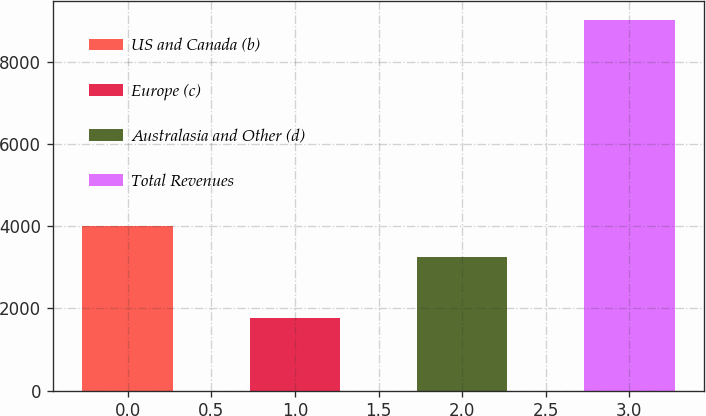Convert chart. <chart><loc_0><loc_0><loc_500><loc_500><bar_chart><fcel>US and Canada (b)<fcel>Europe (c)<fcel>Australasia and Other (d)<fcel>Total Revenues<nl><fcel>3998<fcel>1766<fcel>3260<fcel>9024<nl></chart> 